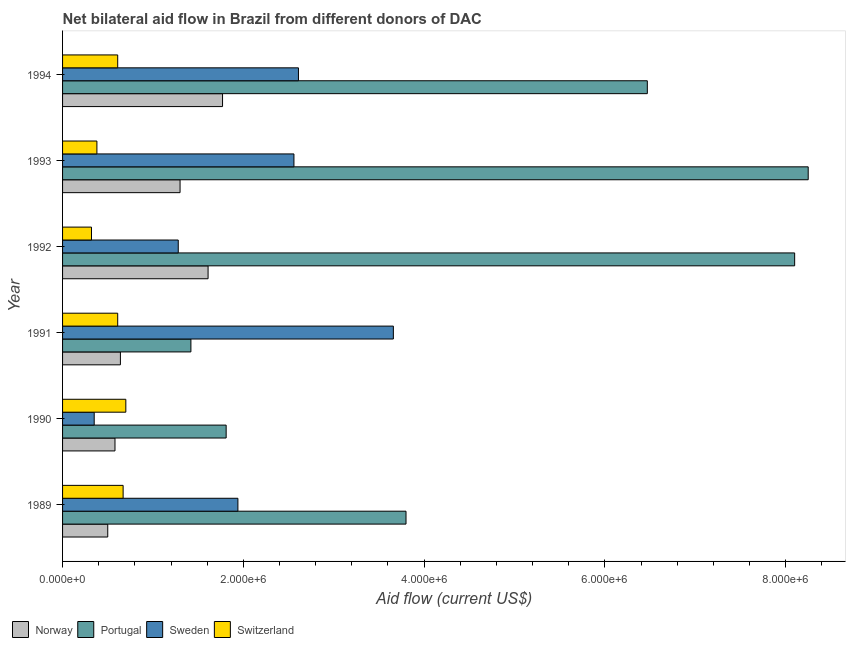How many groups of bars are there?
Your response must be concise. 6. Are the number of bars per tick equal to the number of legend labels?
Your response must be concise. Yes. Are the number of bars on each tick of the Y-axis equal?
Your answer should be very brief. Yes. What is the label of the 4th group of bars from the top?
Your response must be concise. 1991. What is the amount of aid given by norway in 1994?
Provide a short and direct response. 1.77e+06. Across all years, what is the maximum amount of aid given by norway?
Keep it short and to the point. 1.77e+06. Across all years, what is the minimum amount of aid given by switzerland?
Offer a very short reply. 3.20e+05. What is the total amount of aid given by norway in the graph?
Give a very brief answer. 6.40e+06. What is the difference between the amount of aid given by sweden in 1992 and that in 1994?
Offer a very short reply. -1.33e+06. What is the difference between the amount of aid given by portugal in 1991 and the amount of aid given by norway in 1989?
Your response must be concise. 9.20e+05. What is the average amount of aid given by switzerland per year?
Your response must be concise. 5.48e+05. In the year 1989, what is the difference between the amount of aid given by switzerland and amount of aid given by portugal?
Give a very brief answer. -3.13e+06. What is the ratio of the amount of aid given by switzerland in 1993 to that in 1994?
Provide a succinct answer. 0.62. Is the amount of aid given by sweden in 1990 less than that in 1993?
Your response must be concise. Yes. Is the difference between the amount of aid given by sweden in 1989 and 1994 greater than the difference between the amount of aid given by switzerland in 1989 and 1994?
Your answer should be compact. No. What is the difference between the highest and the second highest amount of aid given by portugal?
Your response must be concise. 1.50e+05. What is the difference between the highest and the lowest amount of aid given by sweden?
Give a very brief answer. 3.31e+06. Is it the case that in every year, the sum of the amount of aid given by sweden and amount of aid given by switzerland is greater than the sum of amount of aid given by portugal and amount of aid given by norway?
Your answer should be compact. No. What does the 4th bar from the top in 1992 represents?
Ensure brevity in your answer.  Norway. Is it the case that in every year, the sum of the amount of aid given by norway and amount of aid given by portugal is greater than the amount of aid given by sweden?
Provide a short and direct response. No. How many bars are there?
Keep it short and to the point. 24. Does the graph contain any zero values?
Your answer should be compact. No. Does the graph contain grids?
Provide a succinct answer. No. Where does the legend appear in the graph?
Your answer should be very brief. Bottom left. How are the legend labels stacked?
Give a very brief answer. Horizontal. What is the title of the graph?
Make the answer very short. Net bilateral aid flow in Brazil from different donors of DAC. Does "Financial sector" appear as one of the legend labels in the graph?
Your answer should be compact. No. What is the label or title of the Y-axis?
Ensure brevity in your answer.  Year. What is the Aid flow (current US$) of Norway in 1989?
Make the answer very short. 5.00e+05. What is the Aid flow (current US$) of Portugal in 1989?
Keep it short and to the point. 3.80e+06. What is the Aid flow (current US$) in Sweden in 1989?
Your response must be concise. 1.94e+06. What is the Aid flow (current US$) of Switzerland in 1989?
Your response must be concise. 6.70e+05. What is the Aid flow (current US$) in Norway in 1990?
Make the answer very short. 5.80e+05. What is the Aid flow (current US$) of Portugal in 1990?
Provide a short and direct response. 1.81e+06. What is the Aid flow (current US$) of Norway in 1991?
Make the answer very short. 6.40e+05. What is the Aid flow (current US$) in Portugal in 1991?
Offer a very short reply. 1.42e+06. What is the Aid flow (current US$) in Sweden in 1991?
Give a very brief answer. 3.66e+06. What is the Aid flow (current US$) of Switzerland in 1991?
Offer a terse response. 6.10e+05. What is the Aid flow (current US$) in Norway in 1992?
Give a very brief answer. 1.61e+06. What is the Aid flow (current US$) of Portugal in 1992?
Give a very brief answer. 8.10e+06. What is the Aid flow (current US$) in Sweden in 1992?
Give a very brief answer. 1.28e+06. What is the Aid flow (current US$) in Switzerland in 1992?
Your answer should be very brief. 3.20e+05. What is the Aid flow (current US$) in Norway in 1993?
Keep it short and to the point. 1.30e+06. What is the Aid flow (current US$) in Portugal in 1993?
Your answer should be compact. 8.25e+06. What is the Aid flow (current US$) of Sweden in 1993?
Offer a very short reply. 2.56e+06. What is the Aid flow (current US$) of Norway in 1994?
Offer a very short reply. 1.77e+06. What is the Aid flow (current US$) of Portugal in 1994?
Provide a succinct answer. 6.47e+06. What is the Aid flow (current US$) in Sweden in 1994?
Provide a short and direct response. 2.61e+06. What is the Aid flow (current US$) of Switzerland in 1994?
Provide a succinct answer. 6.10e+05. Across all years, what is the maximum Aid flow (current US$) of Norway?
Ensure brevity in your answer.  1.77e+06. Across all years, what is the maximum Aid flow (current US$) in Portugal?
Provide a short and direct response. 8.25e+06. Across all years, what is the maximum Aid flow (current US$) of Sweden?
Provide a succinct answer. 3.66e+06. Across all years, what is the minimum Aid flow (current US$) in Norway?
Your answer should be very brief. 5.00e+05. Across all years, what is the minimum Aid flow (current US$) in Portugal?
Your answer should be very brief. 1.42e+06. What is the total Aid flow (current US$) of Norway in the graph?
Your response must be concise. 6.40e+06. What is the total Aid flow (current US$) of Portugal in the graph?
Your answer should be very brief. 2.98e+07. What is the total Aid flow (current US$) in Sweden in the graph?
Your answer should be very brief. 1.24e+07. What is the total Aid flow (current US$) of Switzerland in the graph?
Make the answer very short. 3.29e+06. What is the difference between the Aid flow (current US$) in Norway in 1989 and that in 1990?
Your response must be concise. -8.00e+04. What is the difference between the Aid flow (current US$) of Portugal in 1989 and that in 1990?
Offer a terse response. 1.99e+06. What is the difference between the Aid flow (current US$) of Sweden in 1989 and that in 1990?
Give a very brief answer. 1.59e+06. What is the difference between the Aid flow (current US$) of Switzerland in 1989 and that in 1990?
Ensure brevity in your answer.  -3.00e+04. What is the difference between the Aid flow (current US$) in Norway in 1989 and that in 1991?
Your response must be concise. -1.40e+05. What is the difference between the Aid flow (current US$) in Portugal in 1989 and that in 1991?
Your answer should be very brief. 2.38e+06. What is the difference between the Aid flow (current US$) of Sweden in 1989 and that in 1991?
Keep it short and to the point. -1.72e+06. What is the difference between the Aid flow (current US$) of Switzerland in 1989 and that in 1991?
Your answer should be compact. 6.00e+04. What is the difference between the Aid flow (current US$) in Norway in 1989 and that in 1992?
Keep it short and to the point. -1.11e+06. What is the difference between the Aid flow (current US$) in Portugal in 1989 and that in 1992?
Your response must be concise. -4.30e+06. What is the difference between the Aid flow (current US$) in Sweden in 1989 and that in 1992?
Keep it short and to the point. 6.60e+05. What is the difference between the Aid flow (current US$) of Switzerland in 1989 and that in 1992?
Offer a terse response. 3.50e+05. What is the difference between the Aid flow (current US$) of Norway in 1989 and that in 1993?
Make the answer very short. -8.00e+05. What is the difference between the Aid flow (current US$) of Portugal in 1989 and that in 1993?
Keep it short and to the point. -4.45e+06. What is the difference between the Aid flow (current US$) of Sweden in 1989 and that in 1993?
Provide a short and direct response. -6.20e+05. What is the difference between the Aid flow (current US$) in Norway in 1989 and that in 1994?
Make the answer very short. -1.27e+06. What is the difference between the Aid flow (current US$) in Portugal in 1989 and that in 1994?
Offer a terse response. -2.67e+06. What is the difference between the Aid flow (current US$) in Sweden in 1989 and that in 1994?
Keep it short and to the point. -6.70e+05. What is the difference between the Aid flow (current US$) of Norway in 1990 and that in 1991?
Provide a succinct answer. -6.00e+04. What is the difference between the Aid flow (current US$) in Portugal in 1990 and that in 1991?
Provide a short and direct response. 3.90e+05. What is the difference between the Aid flow (current US$) in Sweden in 1990 and that in 1991?
Keep it short and to the point. -3.31e+06. What is the difference between the Aid flow (current US$) of Switzerland in 1990 and that in 1991?
Give a very brief answer. 9.00e+04. What is the difference between the Aid flow (current US$) of Norway in 1990 and that in 1992?
Offer a very short reply. -1.03e+06. What is the difference between the Aid flow (current US$) of Portugal in 1990 and that in 1992?
Your answer should be compact. -6.29e+06. What is the difference between the Aid flow (current US$) in Sweden in 1990 and that in 1992?
Ensure brevity in your answer.  -9.30e+05. What is the difference between the Aid flow (current US$) in Norway in 1990 and that in 1993?
Offer a very short reply. -7.20e+05. What is the difference between the Aid flow (current US$) in Portugal in 1990 and that in 1993?
Your response must be concise. -6.44e+06. What is the difference between the Aid flow (current US$) of Sweden in 1990 and that in 1993?
Offer a very short reply. -2.21e+06. What is the difference between the Aid flow (current US$) in Norway in 1990 and that in 1994?
Provide a succinct answer. -1.19e+06. What is the difference between the Aid flow (current US$) of Portugal in 1990 and that in 1994?
Provide a succinct answer. -4.66e+06. What is the difference between the Aid flow (current US$) of Sweden in 1990 and that in 1994?
Make the answer very short. -2.26e+06. What is the difference between the Aid flow (current US$) in Norway in 1991 and that in 1992?
Offer a terse response. -9.70e+05. What is the difference between the Aid flow (current US$) in Portugal in 1991 and that in 1992?
Ensure brevity in your answer.  -6.68e+06. What is the difference between the Aid flow (current US$) in Sweden in 1991 and that in 1992?
Make the answer very short. 2.38e+06. What is the difference between the Aid flow (current US$) in Switzerland in 1991 and that in 1992?
Make the answer very short. 2.90e+05. What is the difference between the Aid flow (current US$) of Norway in 1991 and that in 1993?
Make the answer very short. -6.60e+05. What is the difference between the Aid flow (current US$) in Portugal in 1991 and that in 1993?
Your answer should be very brief. -6.83e+06. What is the difference between the Aid flow (current US$) in Sweden in 1991 and that in 1993?
Offer a very short reply. 1.10e+06. What is the difference between the Aid flow (current US$) in Norway in 1991 and that in 1994?
Provide a succinct answer. -1.13e+06. What is the difference between the Aid flow (current US$) of Portugal in 1991 and that in 1994?
Provide a succinct answer. -5.05e+06. What is the difference between the Aid flow (current US$) of Sweden in 1991 and that in 1994?
Give a very brief answer. 1.05e+06. What is the difference between the Aid flow (current US$) of Switzerland in 1991 and that in 1994?
Offer a terse response. 0. What is the difference between the Aid flow (current US$) of Sweden in 1992 and that in 1993?
Offer a very short reply. -1.28e+06. What is the difference between the Aid flow (current US$) in Norway in 1992 and that in 1994?
Provide a short and direct response. -1.60e+05. What is the difference between the Aid flow (current US$) of Portugal in 1992 and that in 1994?
Make the answer very short. 1.63e+06. What is the difference between the Aid flow (current US$) in Sweden in 1992 and that in 1994?
Provide a succinct answer. -1.33e+06. What is the difference between the Aid flow (current US$) of Norway in 1993 and that in 1994?
Ensure brevity in your answer.  -4.70e+05. What is the difference between the Aid flow (current US$) in Portugal in 1993 and that in 1994?
Offer a terse response. 1.78e+06. What is the difference between the Aid flow (current US$) of Switzerland in 1993 and that in 1994?
Provide a short and direct response. -2.30e+05. What is the difference between the Aid flow (current US$) in Norway in 1989 and the Aid flow (current US$) in Portugal in 1990?
Your response must be concise. -1.31e+06. What is the difference between the Aid flow (current US$) of Portugal in 1989 and the Aid flow (current US$) of Sweden in 1990?
Keep it short and to the point. 3.45e+06. What is the difference between the Aid flow (current US$) of Portugal in 1989 and the Aid flow (current US$) of Switzerland in 1990?
Provide a short and direct response. 3.10e+06. What is the difference between the Aid flow (current US$) of Sweden in 1989 and the Aid flow (current US$) of Switzerland in 1990?
Keep it short and to the point. 1.24e+06. What is the difference between the Aid flow (current US$) in Norway in 1989 and the Aid flow (current US$) in Portugal in 1991?
Provide a short and direct response. -9.20e+05. What is the difference between the Aid flow (current US$) in Norway in 1989 and the Aid flow (current US$) in Sweden in 1991?
Offer a very short reply. -3.16e+06. What is the difference between the Aid flow (current US$) in Norway in 1989 and the Aid flow (current US$) in Switzerland in 1991?
Provide a succinct answer. -1.10e+05. What is the difference between the Aid flow (current US$) of Portugal in 1989 and the Aid flow (current US$) of Switzerland in 1991?
Give a very brief answer. 3.19e+06. What is the difference between the Aid flow (current US$) of Sweden in 1989 and the Aid flow (current US$) of Switzerland in 1991?
Your answer should be compact. 1.33e+06. What is the difference between the Aid flow (current US$) in Norway in 1989 and the Aid flow (current US$) in Portugal in 1992?
Your answer should be compact. -7.60e+06. What is the difference between the Aid flow (current US$) of Norway in 1989 and the Aid flow (current US$) of Sweden in 1992?
Provide a succinct answer. -7.80e+05. What is the difference between the Aid flow (current US$) in Portugal in 1989 and the Aid flow (current US$) in Sweden in 1992?
Offer a very short reply. 2.52e+06. What is the difference between the Aid flow (current US$) in Portugal in 1989 and the Aid flow (current US$) in Switzerland in 1992?
Offer a terse response. 3.48e+06. What is the difference between the Aid flow (current US$) in Sweden in 1989 and the Aid flow (current US$) in Switzerland in 1992?
Give a very brief answer. 1.62e+06. What is the difference between the Aid flow (current US$) in Norway in 1989 and the Aid flow (current US$) in Portugal in 1993?
Offer a terse response. -7.75e+06. What is the difference between the Aid flow (current US$) in Norway in 1989 and the Aid flow (current US$) in Sweden in 1993?
Offer a very short reply. -2.06e+06. What is the difference between the Aid flow (current US$) of Portugal in 1989 and the Aid flow (current US$) of Sweden in 1993?
Your answer should be very brief. 1.24e+06. What is the difference between the Aid flow (current US$) of Portugal in 1989 and the Aid flow (current US$) of Switzerland in 1993?
Your answer should be compact. 3.42e+06. What is the difference between the Aid flow (current US$) in Sweden in 1989 and the Aid flow (current US$) in Switzerland in 1993?
Your response must be concise. 1.56e+06. What is the difference between the Aid flow (current US$) of Norway in 1989 and the Aid flow (current US$) of Portugal in 1994?
Offer a terse response. -5.97e+06. What is the difference between the Aid flow (current US$) of Norway in 1989 and the Aid flow (current US$) of Sweden in 1994?
Give a very brief answer. -2.11e+06. What is the difference between the Aid flow (current US$) of Portugal in 1989 and the Aid flow (current US$) of Sweden in 1994?
Your answer should be compact. 1.19e+06. What is the difference between the Aid flow (current US$) in Portugal in 1989 and the Aid flow (current US$) in Switzerland in 1994?
Make the answer very short. 3.19e+06. What is the difference between the Aid flow (current US$) of Sweden in 1989 and the Aid flow (current US$) of Switzerland in 1994?
Provide a short and direct response. 1.33e+06. What is the difference between the Aid flow (current US$) in Norway in 1990 and the Aid flow (current US$) in Portugal in 1991?
Your response must be concise. -8.40e+05. What is the difference between the Aid flow (current US$) in Norway in 1990 and the Aid flow (current US$) in Sweden in 1991?
Your answer should be compact. -3.08e+06. What is the difference between the Aid flow (current US$) of Norway in 1990 and the Aid flow (current US$) of Switzerland in 1991?
Your answer should be compact. -3.00e+04. What is the difference between the Aid flow (current US$) in Portugal in 1990 and the Aid flow (current US$) in Sweden in 1991?
Your answer should be very brief. -1.85e+06. What is the difference between the Aid flow (current US$) of Portugal in 1990 and the Aid flow (current US$) of Switzerland in 1991?
Keep it short and to the point. 1.20e+06. What is the difference between the Aid flow (current US$) in Norway in 1990 and the Aid flow (current US$) in Portugal in 1992?
Offer a very short reply. -7.52e+06. What is the difference between the Aid flow (current US$) of Norway in 1990 and the Aid flow (current US$) of Sweden in 1992?
Make the answer very short. -7.00e+05. What is the difference between the Aid flow (current US$) in Portugal in 1990 and the Aid flow (current US$) in Sweden in 1992?
Provide a short and direct response. 5.30e+05. What is the difference between the Aid flow (current US$) in Portugal in 1990 and the Aid flow (current US$) in Switzerland in 1992?
Ensure brevity in your answer.  1.49e+06. What is the difference between the Aid flow (current US$) of Sweden in 1990 and the Aid flow (current US$) of Switzerland in 1992?
Provide a succinct answer. 3.00e+04. What is the difference between the Aid flow (current US$) in Norway in 1990 and the Aid flow (current US$) in Portugal in 1993?
Ensure brevity in your answer.  -7.67e+06. What is the difference between the Aid flow (current US$) of Norway in 1990 and the Aid flow (current US$) of Sweden in 1993?
Offer a terse response. -1.98e+06. What is the difference between the Aid flow (current US$) of Portugal in 1990 and the Aid flow (current US$) of Sweden in 1993?
Offer a terse response. -7.50e+05. What is the difference between the Aid flow (current US$) in Portugal in 1990 and the Aid flow (current US$) in Switzerland in 1993?
Keep it short and to the point. 1.43e+06. What is the difference between the Aid flow (current US$) of Sweden in 1990 and the Aid flow (current US$) of Switzerland in 1993?
Provide a succinct answer. -3.00e+04. What is the difference between the Aid flow (current US$) of Norway in 1990 and the Aid flow (current US$) of Portugal in 1994?
Keep it short and to the point. -5.89e+06. What is the difference between the Aid flow (current US$) of Norway in 1990 and the Aid flow (current US$) of Sweden in 1994?
Offer a terse response. -2.03e+06. What is the difference between the Aid flow (current US$) of Norway in 1990 and the Aid flow (current US$) of Switzerland in 1994?
Offer a very short reply. -3.00e+04. What is the difference between the Aid flow (current US$) in Portugal in 1990 and the Aid flow (current US$) in Sweden in 1994?
Provide a short and direct response. -8.00e+05. What is the difference between the Aid flow (current US$) in Portugal in 1990 and the Aid flow (current US$) in Switzerland in 1994?
Give a very brief answer. 1.20e+06. What is the difference between the Aid flow (current US$) of Sweden in 1990 and the Aid flow (current US$) of Switzerland in 1994?
Make the answer very short. -2.60e+05. What is the difference between the Aid flow (current US$) of Norway in 1991 and the Aid flow (current US$) of Portugal in 1992?
Your response must be concise. -7.46e+06. What is the difference between the Aid flow (current US$) of Norway in 1991 and the Aid flow (current US$) of Sweden in 1992?
Your answer should be very brief. -6.40e+05. What is the difference between the Aid flow (current US$) of Portugal in 1991 and the Aid flow (current US$) of Sweden in 1992?
Offer a terse response. 1.40e+05. What is the difference between the Aid flow (current US$) of Portugal in 1991 and the Aid flow (current US$) of Switzerland in 1992?
Your answer should be compact. 1.10e+06. What is the difference between the Aid flow (current US$) in Sweden in 1991 and the Aid flow (current US$) in Switzerland in 1992?
Your answer should be very brief. 3.34e+06. What is the difference between the Aid flow (current US$) of Norway in 1991 and the Aid flow (current US$) of Portugal in 1993?
Give a very brief answer. -7.61e+06. What is the difference between the Aid flow (current US$) in Norway in 1991 and the Aid flow (current US$) in Sweden in 1993?
Keep it short and to the point. -1.92e+06. What is the difference between the Aid flow (current US$) of Norway in 1991 and the Aid flow (current US$) of Switzerland in 1993?
Ensure brevity in your answer.  2.60e+05. What is the difference between the Aid flow (current US$) of Portugal in 1991 and the Aid flow (current US$) of Sweden in 1993?
Provide a succinct answer. -1.14e+06. What is the difference between the Aid flow (current US$) of Portugal in 1991 and the Aid flow (current US$) of Switzerland in 1993?
Give a very brief answer. 1.04e+06. What is the difference between the Aid flow (current US$) in Sweden in 1991 and the Aid flow (current US$) in Switzerland in 1993?
Keep it short and to the point. 3.28e+06. What is the difference between the Aid flow (current US$) of Norway in 1991 and the Aid flow (current US$) of Portugal in 1994?
Provide a succinct answer. -5.83e+06. What is the difference between the Aid flow (current US$) of Norway in 1991 and the Aid flow (current US$) of Sweden in 1994?
Your answer should be compact. -1.97e+06. What is the difference between the Aid flow (current US$) in Portugal in 1991 and the Aid flow (current US$) in Sweden in 1994?
Make the answer very short. -1.19e+06. What is the difference between the Aid flow (current US$) of Portugal in 1991 and the Aid flow (current US$) of Switzerland in 1994?
Keep it short and to the point. 8.10e+05. What is the difference between the Aid flow (current US$) of Sweden in 1991 and the Aid flow (current US$) of Switzerland in 1994?
Provide a short and direct response. 3.05e+06. What is the difference between the Aid flow (current US$) in Norway in 1992 and the Aid flow (current US$) in Portugal in 1993?
Your answer should be compact. -6.64e+06. What is the difference between the Aid flow (current US$) in Norway in 1992 and the Aid flow (current US$) in Sweden in 1993?
Ensure brevity in your answer.  -9.50e+05. What is the difference between the Aid flow (current US$) of Norway in 1992 and the Aid flow (current US$) of Switzerland in 1993?
Make the answer very short. 1.23e+06. What is the difference between the Aid flow (current US$) in Portugal in 1992 and the Aid flow (current US$) in Sweden in 1993?
Your answer should be compact. 5.54e+06. What is the difference between the Aid flow (current US$) of Portugal in 1992 and the Aid flow (current US$) of Switzerland in 1993?
Give a very brief answer. 7.72e+06. What is the difference between the Aid flow (current US$) in Norway in 1992 and the Aid flow (current US$) in Portugal in 1994?
Your answer should be compact. -4.86e+06. What is the difference between the Aid flow (current US$) of Portugal in 1992 and the Aid flow (current US$) of Sweden in 1994?
Your answer should be compact. 5.49e+06. What is the difference between the Aid flow (current US$) of Portugal in 1992 and the Aid flow (current US$) of Switzerland in 1994?
Your response must be concise. 7.49e+06. What is the difference between the Aid flow (current US$) of Sweden in 1992 and the Aid flow (current US$) of Switzerland in 1994?
Make the answer very short. 6.70e+05. What is the difference between the Aid flow (current US$) of Norway in 1993 and the Aid flow (current US$) of Portugal in 1994?
Provide a short and direct response. -5.17e+06. What is the difference between the Aid flow (current US$) of Norway in 1993 and the Aid flow (current US$) of Sweden in 1994?
Give a very brief answer. -1.31e+06. What is the difference between the Aid flow (current US$) of Norway in 1993 and the Aid flow (current US$) of Switzerland in 1994?
Offer a terse response. 6.90e+05. What is the difference between the Aid flow (current US$) in Portugal in 1993 and the Aid flow (current US$) in Sweden in 1994?
Provide a short and direct response. 5.64e+06. What is the difference between the Aid flow (current US$) of Portugal in 1993 and the Aid flow (current US$) of Switzerland in 1994?
Make the answer very short. 7.64e+06. What is the difference between the Aid flow (current US$) of Sweden in 1993 and the Aid flow (current US$) of Switzerland in 1994?
Make the answer very short. 1.95e+06. What is the average Aid flow (current US$) of Norway per year?
Keep it short and to the point. 1.07e+06. What is the average Aid flow (current US$) in Portugal per year?
Your response must be concise. 4.98e+06. What is the average Aid flow (current US$) in Sweden per year?
Give a very brief answer. 2.07e+06. What is the average Aid flow (current US$) in Switzerland per year?
Make the answer very short. 5.48e+05. In the year 1989, what is the difference between the Aid flow (current US$) of Norway and Aid flow (current US$) of Portugal?
Give a very brief answer. -3.30e+06. In the year 1989, what is the difference between the Aid flow (current US$) in Norway and Aid flow (current US$) in Sweden?
Your answer should be very brief. -1.44e+06. In the year 1989, what is the difference between the Aid flow (current US$) of Norway and Aid flow (current US$) of Switzerland?
Offer a very short reply. -1.70e+05. In the year 1989, what is the difference between the Aid flow (current US$) in Portugal and Aid flow (current US$) in Sweden?
Keep it short and to the point. 1.86e+06. In the year 1989, what is the difference between the Aid flow (current US$) of Portugal and Aid flow (current US$) of Switzerland?
Keep it short and to the point. 3.13e+06. In the year 1989, what is the difference between the Aid flow (current US$) in Sweden and Aid flow (current US$) in Switzerland?
Provide a succinct answer. 1.27e+06. In the year 1990, what is the difference between the Aid flow (current US$) of Norway and Aid flow (current US$) of Portugal?
Your answer should be very brief. -1.23e+06. In the year 1990, what is the difference between the Aid flow (current US$) in Norway and Aid flow (current US$) in Sweden?
Your answer should be very brief. 2.30e+05. In the year 1990, what is the difference between the Aid flow (current US$) in Portugal and Aid flow (current US$) in Sweden?
Your response must be concise. 1.46e+06. In the year 1990, what is the difference between the Aid flow (current US$) of Portugal and Aid flow (current US$) of Switzerland?
Your response must be concise. 1.11e+06. In the year 1990, what is the difference between the Aid flow (current US$) in Sweden and Aid flow (current US$) in Switzerland?
Keep it short and to the point. -3.50e+05. In the year 1991, what is the difference between the Aid flow (current US$) in Norway and Aid flow (current US$) in Portugal?
Your response must be concise. -7.80e+05. In the year 1991, what is the difference between the Aid flow (current US$) in Norway and Aid flow (current US$) in Sweden?
Make the answer very short. -3.02e+06. In the year 1991, what is the difference between the Aid flow (current US$) in Portugal and Aid flow (current US$) in Sweden?
Your response must be concise. -2.24e+06. In the year 1991, what is the difference between the Aid flow (current US$) in Portugal and Aid flow (current US$) in Switzerland?
Provide a succinct answer. 8.10e+05. In the year 1991, what is the difference between the Aid flow (current US$) in Sweden and Aid flow (current US$) in Switzerland?
Make the answer very short. 3.05e+06. In the year 1992, what is the difference between the Aid flow (current US$) in Norway and Aid flow (current US$) in Portugal?
Make the answer very short. -6.49e+06. In the year 1992, what is the difference between the Aid flow (current US$) of Norway and Aid flow (current US$) of Sweden?
Your answer should be compact. 3.30e+05. In the year 1992, what is the difference between the Aid flow (current US$) of Norway and Aid flow (current US$) of Switzerland?
Ensure brevity in your answer.  1.29e+06. In the year 1992, what is the difference between the Aid flow (current US$) of Portugal and Aid flow (current US$) of Sweden?
Make the answer very short. 6.82e+06. In the year 1992, what is the difference between the Aid flow (current US$) of Portugal and Aid flow (current US$) of Switzerland?
Your response must be concise. 7.78e+06. In the year 1992, what is the difference between the Aid flow (current US$) in Sweden and Aid flow (current US$) in Switzerland?
Your answer should be very brief. 9.60e+05. In the year 1993, what is the difference between the Aid flow (current US$) in Norway and Aid flow (current US$) in Portugal?
Your answer should be very brief. -6.95e+06. In the year 1993, what is the difference between the Aid flow (current US$) of Norway and Aid flow (current US$) of Sweden?
Offer a terse response. -1.26e+06. In the year 1993, what is the difference between the Aid flow (current US$) in Norway and Aid flow (current US$) in Switzerland?
Make the answer very short. 9.20e+05. In the year 1993, what is the difference between the Aid flow (current US$) in Portugal and Aid flow (current US$) in Sweden?
Provide a short and direct response. 5.69e+06. In the year 1993, what is the difference between the Aid flow (current US$) of Portugal and Aid flow (current US$) of Switzerland?
Your response must be concise. 7.87e+06. In the year 1993, what is the difference between the Aid flow (current US$) in Sweden and Aid flow (current US$) in Switzerland?
Ensure brevity in your answer.  2.18e+06. In the year 1994, what is the difference between the Aid flow (current US$) of Norway and Aid flow (current US$) of Portugal?
Offer a terse response. -4.70e+06. In the year 1994, what is the difference between the Aid flow (current US$) in Norway and Aid flow (current US$) in Sweden?
Your answer should be compact. -8.40e+05. In the year 1994, what is the difference between the Aid flow (current US$) in Norway and Aid flow (current US$) in Switzerland?
Provide a short and direct response. 1.16e+06. In the year 1994, what is the difference between the Aid flow (current US$) in Portugal and Aid flow (current US$) in Sweden?
Give a very brief answer. 3.86e+06. In the year 1994, what is the difference between the Aid flow (current US$) in Portugal and Aid flow (current US$) in Switzerland?
Your response must be concise. 5.86e+06. In the year 1994, what is the difference between the Aid flow (current US$) of Sweden and Aid flow (current US$) of Switzerland?
Your answer should be compact. 2.00e+06. What is the ratio of the Aid flow (current US$) of Norway in 1989 to that in 1990?
Ensure brevity in your answer.  0.86. What is the ratio of the Aid flow (current US$) of Portugal in 1989 to that in 1990?
Provide a short and direct response. 2.1. What is the ratio of the Aid flow (current US$) in Sweden in 1989 to that in 1990?
Your answer should be very brief. 5.54. What is the ratio of the Aid flow (current US$) of Switzerland in 1989 to that in 1990?
Keep it short and to the point. 0.96. What is the ratio of the Aid flow (current US$) in Norway in 1989 to that in 1991?
Make the answer very short. 0.78. What is the ratio of the Aid flow (current US$) of Portugal in 1989 to that in 1991?
Offer a very short reply. 2.68. What is the ratio of the Aid flow (current US$) of Sweden in 1989 to that in 1991?
Provide a short and direct response. 0.53. What is the ratio of the Aid flow (current US$) of Switzerland in 1989 to that in 1991?
Your response must be concise. 1.1. What is the ratio of the Aid flow (current US$) of Norway in 1989 to that in 1992?
Provide a succinct answer. 0.31. What is the ratio of the Aid flow (current US$) of Portugal in 1989 to that in 1992?
Give a very brief answer. 0.47. What is the ratio of the Aid flow (current US$) of Sweden in 1989 to that in 1992?
Make the answer very short. 1.52. What is the ratio of the Aid flow (current US$) of Switzerland in 1989 to that in 1992?
Ensure brevity in your answer.  2.09. What is the ratio of the Aid flow (current US$) of Norway in 1989 to that in 1993?
Your response must be concise. 0.38. What is the ratio of the Aid flow (current US$) of Portugal in 1989 to that in 1993?
Keep it short and to the point. 0.46. What is the ratio of the Aid flow (current US$) of Sweden in 1989 to that in 1993?
Your answer should be compact. 0.76. What is the ratio of the Aid flow (current US$) in Switzerland in 1989 to that in 1993?
Offer a very short reply. 1.76. What is the ratio of the Aid flow (current US$) of Norway in 1989 to that in 1994?
Give a very brief answer. 0.28. What is the ratio of the Aid flow (current US$) in Portugal in 1989 to that in 1994?
Offer a very short reply. 0.59. What is the ratio of the Aid flow (current US$) in Sweden in 1989 to that in 1994?
Your response must be concise. 0.74. What is the ratio of the Aid flow (current US$) of Switzerland in 1989 to that in 1994?
Your answer should be very brief. 1.1. What is the ratio of the Aid flow (current US$) of Norway in 1990 to that in 1991?
Offer a terse response. 0.91. What is the ratio of the Aid flow (current US$) in Portugal in 1990 to that in 1991?
Keep it short and to the point. 1.27. What is the ratio of the Aid flow (current US$) in Sweden in 1990 to that in 1991?
Provide a short and direct response. 0.1. What is the ratio of the Aid flow (current US$) in Switzerland in 1990 to that in 1991?
Offer a terse response. 1.15. What is the ratio of the Aid flow (current US$) in Norway in 1990 to that in 1992?
Ensure brevity in your answer.  0.36. What is the ratio of the Aid flow (current US$) in Portugal in 1990 to that in 1992?
Provide a succinct answer. 0.22. What is the ratio of the Aid flow (current US$) in Sweden in 1990 to that in 1992?
Keep it short and to the point. 0.27. What is the ratio of the Aid flow (current US$) in Switzerland in 1990 to that in 1992?
Provide a short and direct response. 2.19. What is the ratio of the Aid flow (current US$) of Norway in 1990 to that in 1993?
Ensure brevity in your answer.  0.45. What is the ratio of the Aid flow (current US$) of Portugal in 1990 to that in 1993?
Make the answer very short. 0.22. What is the ratio of the Aid flow (current US$) of Sweden in 1990 to that in 1993?
Make the answer very short. 0.14. What is the ratio of the Aid flow (current US$) in Switzerland in 1990 to that in 1993?
Your response must be concise. 1.84. What is the ratio of the Aid flow (current US$) of Norway in 1990 to that in 1994?
Your answer should be very brief. 0.33. What is the ratio of the Aid flow (current US$) of Portugal in 1990 to that in 1994?
Offer a very short reply. 0.28. What is the ratio of the Aid flow (current US$) of Sweden in 1990 to that in 1994?
Your answer should be compact. 0.13. What is the ratio of the Aid flow (current US$) in Switzerland in 1990 to that in 1994?
Make the answer very short. 1.15. What is the ratio of the Aid flow (current US$) of Norway in 1991 to that in 1992?
Offer a terse response. 0.4. What is the ratio of the Aid flow (current US$) in Portugal in 1991 to that in 1992?
Keep it short and to the point. 0.18. What is the ratio of the Aid flow (current US$) in Sweden in 1991 to that in 1992?
Your answer should be very brief. 2.86. What is the ratio of the Aid flow (current US$) in Switzerland in 1991 to that in 1992?
Give a very brief answer. 1.91. What is the ratio of the Aid flow (current US$) in Norway in 1991 to that in 1993?
Your answer should be compact. 0.49. What is the ratio of the Aid flow (current US$) in Portugal in 1991 to that in 1993?
Keep it short and to the point. 0.17. What is the ratio of the Aid flow (current US$) in Sweden in 1991 to that in 1993?
Ensure brevity in your answer.  1.43. What is the ratio of the Aid flow (current US$) of Switzerland in 1991 to that in 1993?
Your answer should be compact. 1.61. What is the ratio of the Aid flow (current US$) in Norway in 1991 to that in 1994?
Make the answer very short. 0.36. What is the ratio of the Aid flow (current US$) of Portugal in 1991 to that in 1994?
Make the answer very short. 0.22. What is the ratio of the Aid flow (current US$) of Sweden in 1991 to that in 1994?
Offer a terse response. 1.4. What is the ratio of the Aid flow (current US$) in Switzerland in 1991 to that in 1994?
Your answer should be very brief. 1. What is the ratio of the Aid flow (current US$) in Norway in 1992 to that in 1993?
Offer a terse response. 1.24. What is the ratio of the Aid flow (current US$) of Portugal in 1992 to that in 1993?
Offer a very short reply. 0.98. What is the ratio of the Aid flow (current US$) of Switzerland in 1992 to that in 1993?
Your answer should be compact. 0.84. What is the ratio of the Aid flow (current US$) of Norway in 1992 to that in 1994?
Make the answer very short. 0.91. What is the ratio of the Aid flow (current US$) in Portugal in 1992 to that in 1994?
Your answer should be compact. 1.25. What is the ratio of the Aid flow (current US$) of Sweden in 1992 to that in 1994?
Your answer should be very brief. 0.49. What is the ratio of the Aid flow (current US$) in Switzerland in 1992 to that in 1994?
Your response must be concise. 0.52. What is the ratio of the Aid flow (current US$) of Norway in 1993 to that in 1994?
Your answer should be compact. 0.73. What is the ratio of the Aid flow (current US$) of Portugal in 1993 to that in 1994?
Keep it short and to the point. 1.28. What is the ratio of the Aid flow (current US$) in Sweden in 1993 to that in 1994?
Your answer should be compact. 0.98. What is the ratio of the Aid flow (current US$) of Switzerland in 1993 to that in 1994?
Your answer should be compact. 0.62. What is the difference between the highest and the second highest Aid flow (current US$) of Norway?
Offer a very short reply. 1.60e+05. What is the difference between the highest and the second highest Aid flow (current US$) of Sweden?
Your answer should be very brief. 1.05e+06. What is the difference between the highest and the second highest Aid flow (current US$) of Switzerland?
Your response must be concise. 3.00e+04. What is the difference between the highest and the lowest Aid flow (current US$) of Norway?
Your answer should be compact. 1.27e+06. What is the difference between the highest and the lowest Aid flow (current US$) of Portugal?
Give a very brief answer. 6.83e+06. What is the difference between the highest and the lowest Aid flow (current US$) of Sweden?
Provide a short and direct response. 3.31e+06. What is the difference between the highest and the lowest Aid flow (current US$) of Switzerland?
Ensure brevity in your answer.  3.80e+05. 